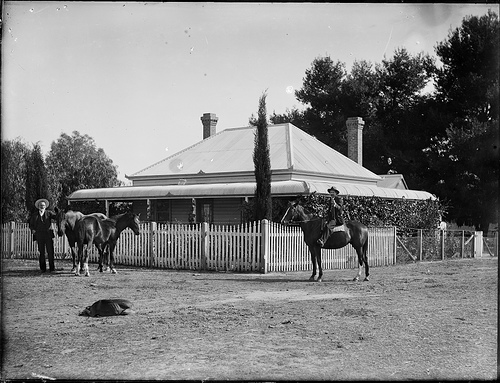How many horses are pictured? 3 